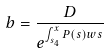Convert formula to latex. <formula><loc_0><loc_0><loc_500><loc_500>b = \frac { D } { e ^ { \int _ { s _ { 4 } } ^ { x } P ( s ) w s } }</formula> 